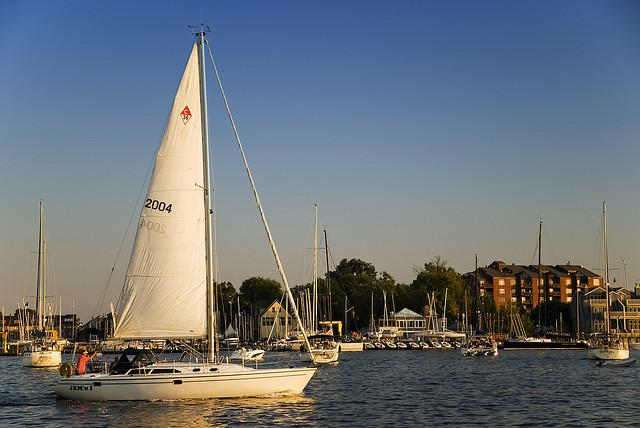Is this a lake?
Answer briefly. Yes. What is the weather like?
Quick response, please. Sunny. Where is this?
Give a very brief answer. Harbor. How many of the boats' sails are up?
Keep it brief. 1. 